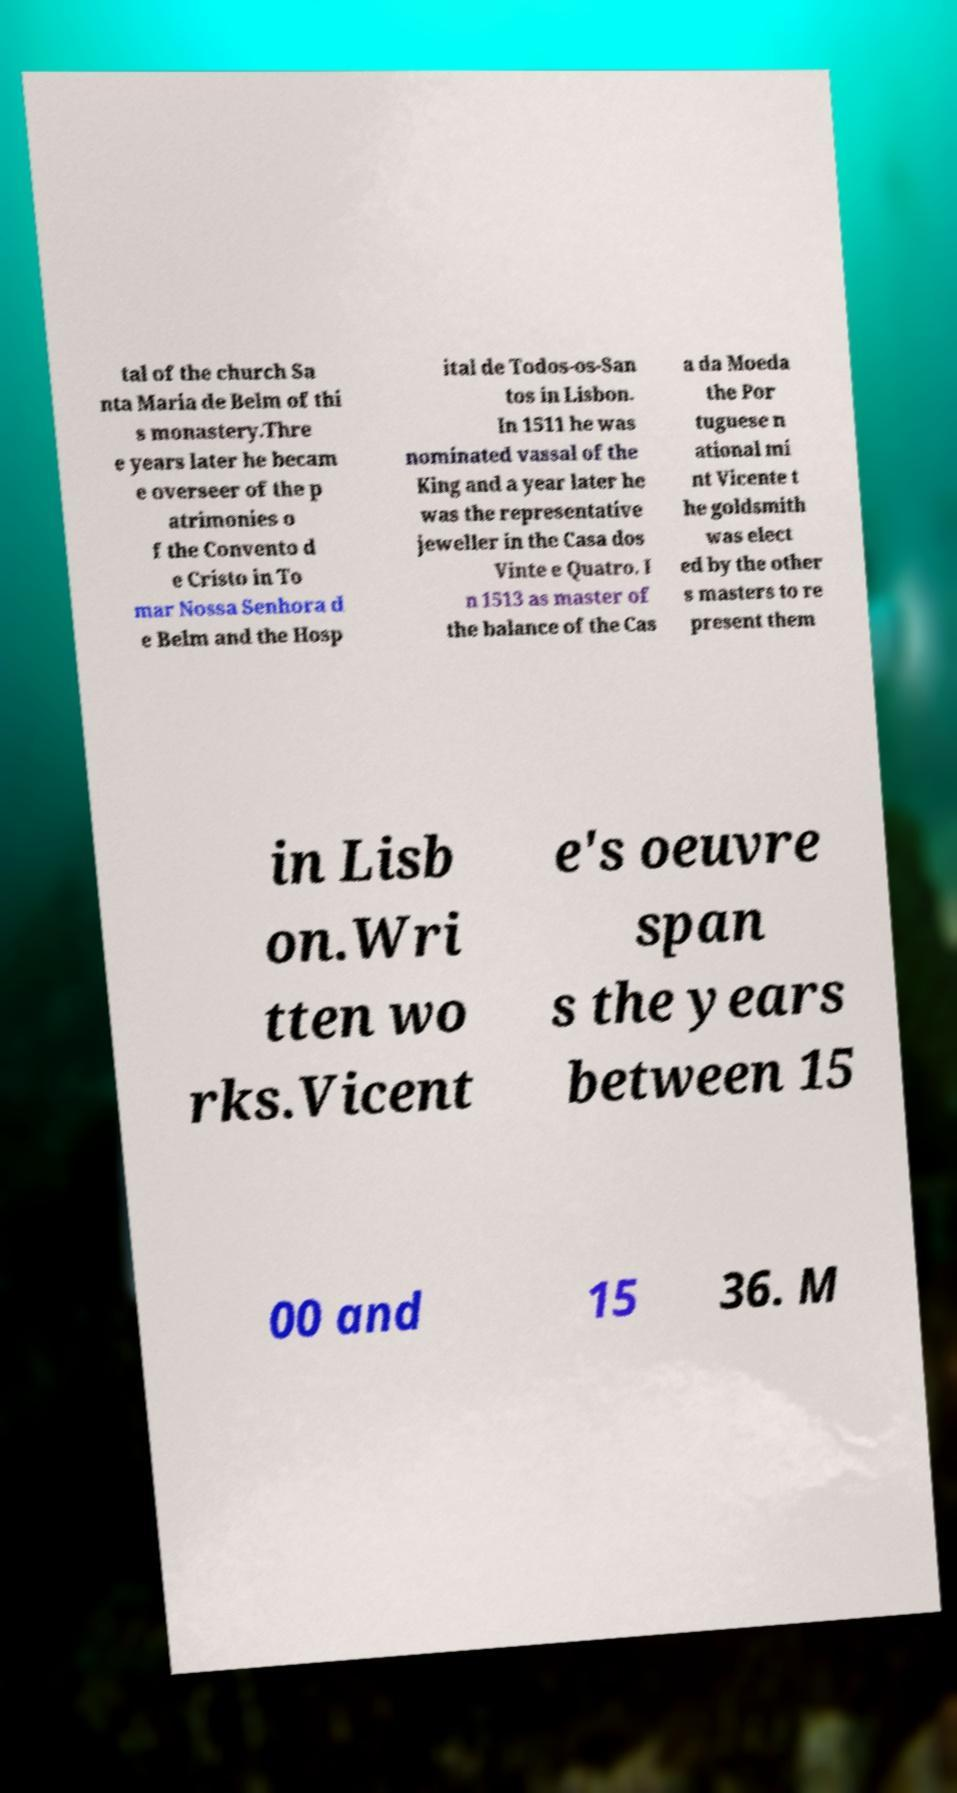I need the written content from this picture converted into text. Can you do that? tal of the church Sa nta Maria de Belm of thi s monastery.Thre e years later he becam e overseer of the p atrimonies o f the Convento d e Cristo in To mar Nossa Senhora d e Belm and the Hosp ital de Todos-os-San tos in Lisbon. In 1511 he was nominated vassal of the King and a year later he was the representative jeweller in the Casa dos Vinte e Quatro. I n 1513 as master of the balance of the Cas a da Moeda the Por tuguese n ational mi nt Vicente t he goldsmith was elect ed by the other s masters to re present them in Lisb on.Wri tten wo rks.Vicent e's oeuvre span s the years between 15 00 and 15 36. M 